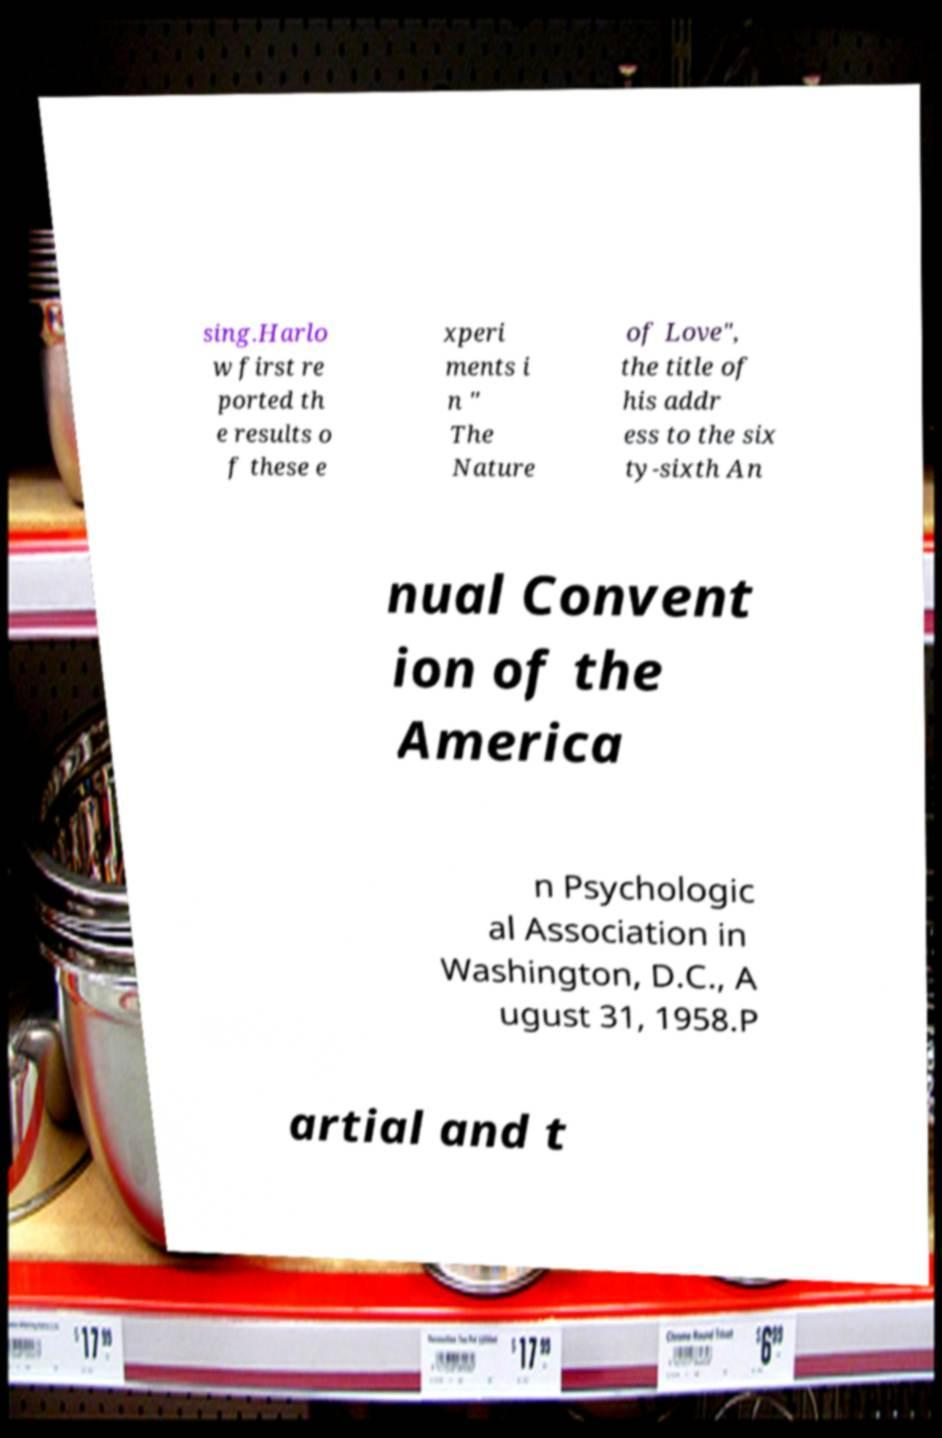Could you extract and type out the text from this image? sing.Harlo w first re ported th e results o f these e xperi ments i n " The Nature of Love", the title of his addr ess to the six ty-sixth An nual Convent ion of the America n Psychologic al Association in Washington, D.C., A ugust 31, 1958.P artial and t 